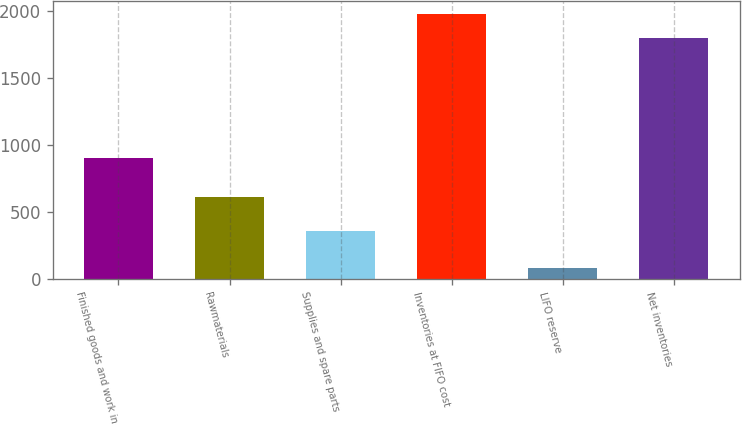<chart> <loc_0><loc_0><loc_500><loc_500><bar_chart><fcel>Finished goods and work in<fcel>Rawmaterials<fcel>Supplies and spare parts<fcel>Inventories at FIFO cost<fcel>LIFO reserve<fcel>Net inventories<nl><fcel>905<fcel>614.2<fcel>360.7<fcel>1977.03<fcel>82.6<fcel>1797.3<nl></chart> 